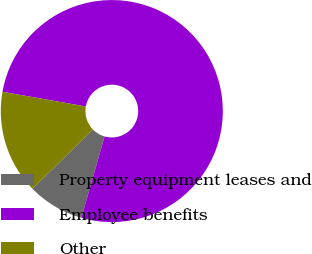<chart> <loc_0><loc_0><loc_500><loc_500><pie_chart><fcel>Property equipment leases and<fcel>Employee benefits<fcel>Other<nl><fcel>8.26%<fcel>76.64%<fcel>15.1%<nl></chart> 